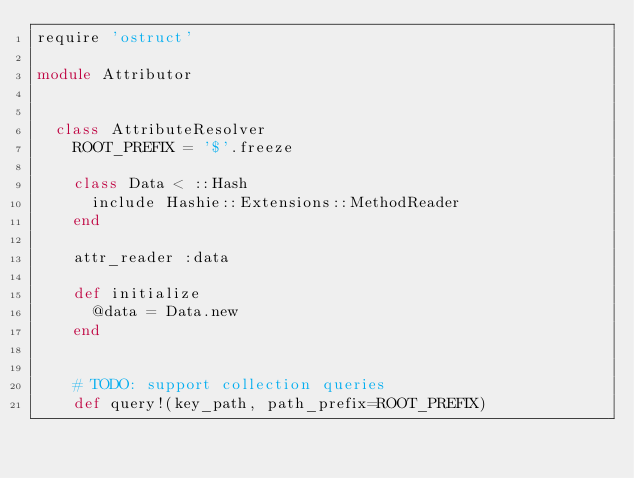<code> <loc_0><loc_0><loc_500><loc_500><_Ruby_>require 'ostruct'

module Attributor


  class AttributeResolver
    ROOT_PREFIX = '$'.freeze

    class Data < ::Hash
      include Hashie::Extensions::MethodReader
    end

    attr_reader :data

    def initialize
      @data = Data.new
    end


    # TODO: support collection queries
    def query!(key_path, path_prefix=ROOT_PREFIX)</code> 